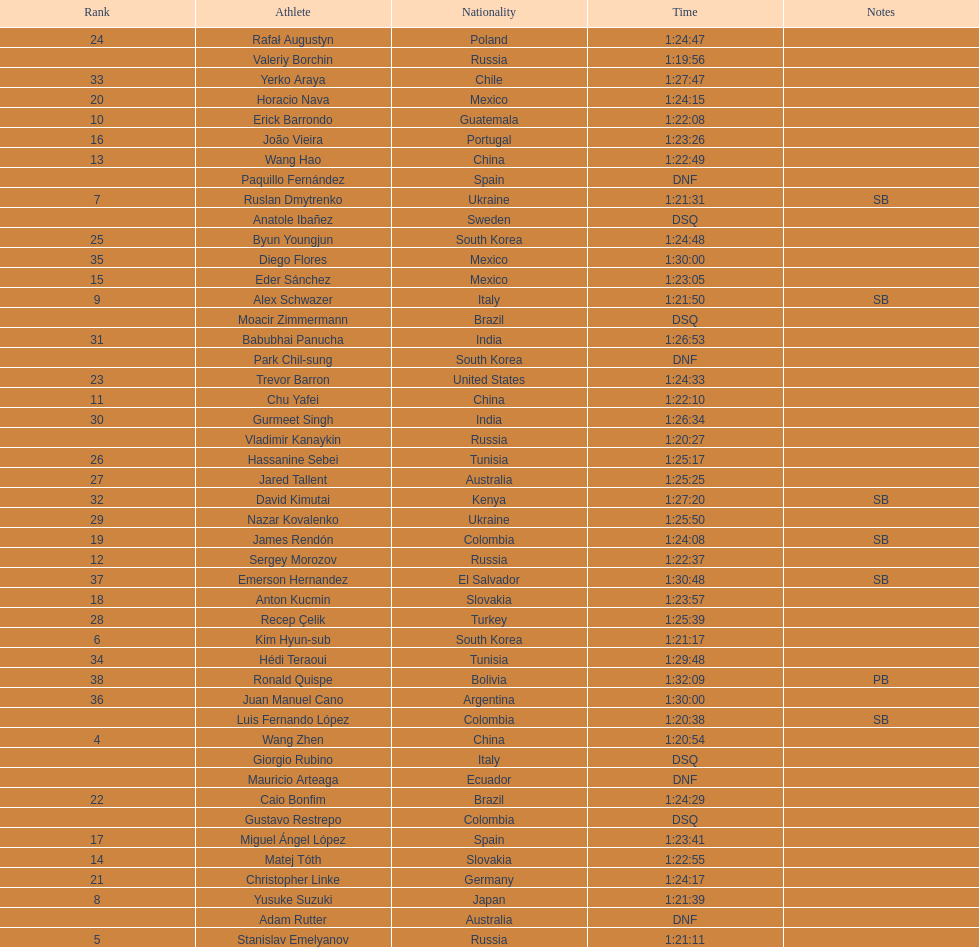What is the number of japanese in the top 10? 1. 